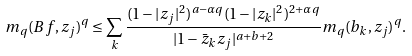<formula> <loc_0><loc_0><loc_500><loc_500>m _ { q } ( B f , z _ { j } ) ^ { q } \leq \sum _ { k } \frac { ( 1 - | z _ { j } | ^ { 2 } ) ^ { a - \alpha q } ( 1 - | z _ { k } | ^ { 2 } ) ^ { 2 + \alpha q } } { | 1 - \bar { z } _ { k } z _ { j } | ^ { a + b + 2 } } m _ { q } ( b _ { k } , z _ { j } ) ^ { q } .</formula> 